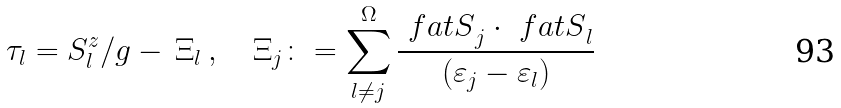Convert formula to latex. <formula><loc_0><loc_0><loc_500><loc_500>\tau _ { l } = S ^ { z } _ { l } / g - \, \Xi _ { l } \, , \quad \Xi _ { j } \colon = \sum _ { l \neq j } ^ { \Omega } { \frac { { \ f a t { S } } _ { j } \cdot { \ f a t { S } } _ { l } } { ( \varepsilon _ { j } - \varepsilon _ { l } ) } }</formula> 